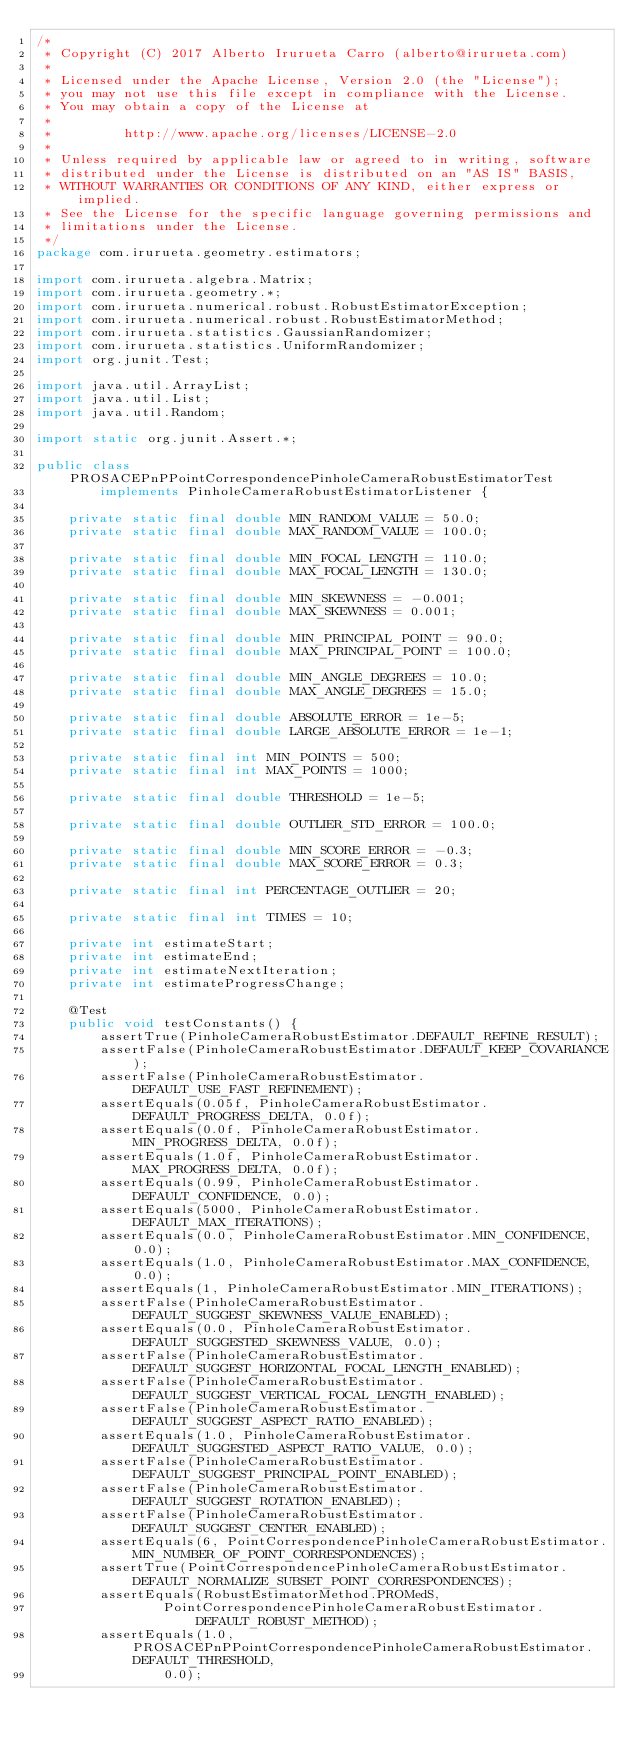Convert code to text. <code><loc_0><loc_0><loc_500><loc_500><_Java_>/*
 * Copyright (C) 2017 Alberto Irurueta Carro (alberto@irurueta.com)
 *
 * Licensed under the Apache License, Version 2.0 (the "License");
 * you may not use this file except in compliance with the License.
 * You may obtain a copy of the License at
 *
 *         http://www.apache.org/licenses/LICENSE-2.0
 *
 * Unless required by applicable law or agreed to in writing, software
 * distributed under the License is distributed on an "AS IS" BASIS,
 * WITHOUT WARRANTIES OR CONDITIONS OF ANY KIND, either express or implied.
 * See the License for the specific language governing permissions and
 * limitations under the License.
 */
package com.irurueta.geometry.estimators;

import com.irurueta.algebra.Matrix;
import com.irurueta.geometry.*;
import com.irurueta.numerical.robust.RobustEstimatorException;
import com.irurueta.numerical.robust.RobustEstimatorMethod;
import com.irurueta.statistics.GaussianRandomizer;
import com.irurueta.statistics.UniformRandomizer;
import org.junit.Test;

import java.util.ArrayList;
import java.util.List;
import java.util.Random;

import static org.junit.Assert.*;

public class PROSACEPnPPointCorrespondencePinholeCameraRobustEstimatorTest
        implements PinholeCameraRobustEstimatorListener {

    private static final double MIN_RANDOM_VALUE = 50.0;
    private static final double MAX_RANDOM_VALUE = 100.0;

    private static final double MIN_FOCAL_LENGTH = 110.0;
    private static final double MAX_FOCAL_LENGTH = 130.0;

    private static final double MIN_SKEWNESS = -0.001;
    private static final double MAX_SKEWNESS = 0.001;

    private static final double MIN_PRINCIPAL_POINT = 90.0;
    private static final double MAX_PRINCIPAL_POINT = 100.0;

    private static final double MIN_ANGLE_DEGREES = 10.0;
    private static final double MAX_ANGLE_DEGREES = 15.0;

    private static final double ABSOLUTE_ERROR = 1e-5;
    private static final double LARGE_ABSOLUTE_ERROR = 1e-1;

    private static final int MIN_POINTS = 500;
    private static final int MAX_POINTS = 1000;

    private static final double THRESHOLD = 1e-5;

    private static final double OUTLIER_STD_ERROR = 100.0;

    private static final double MIN_SCORE_ERROR = -0.3;
    private static final double MAX_SCORE_ERROR = 0.3;

    private static final int PERCENTAGE_OUTLIER = 20;

    private static final int TIMES = 10;

    private int estimateStart;
    private int estimateEnd;
    private int estimateNextIteration;
    private int estimateProgressChange;

    @Test
    public void testConstants() {
        assertTrue(PinholeCameraRobustEstimator.DEFAULT_REFINE_RESULT);
        assertFalse(PinholeCameraRobustEstimator.DEFAULT_KEEP_COVARIANCE);
        assertFalse(PinholeCameraRobustEstimator.DEFAULT_USE_FAST_REFINEMENT);
        assertEquals(0.05f, PinholeCameraRobustEstimator.DEFAULT_PROGRESS_DELTA, 0.0f);
        assertEquals(0.0f, PinholeCameraRobustEstimator.MIN_PROGRESS_DELTA, 0.0f);
        assertEquals(1.0f, PinholeCameraRobustEstimator.MAX_PROGRESS_DELTA, 0.0f);
        assertEquals(0.99, PinholeCameraRobustEstimator.DEFAULT_CONFIDENCE, 0.0);
        assertEquals(5000, PinholeCameraRobustEstimator.DEFAULT_MAX_ITERATIONS);
        assertEquals(0.0, PinholeCameraRobustEstimator.MIN_CONFIDENCE, 0.0);
        assertEquals(1.0, PinholeCameraRobustEstimator.MAX_CONFIDENCE, 0.0);
        assertEquals(1, PinholeCameraRobustEstimator.MIN_ITERATIONS);
        assertFalse(PinholeCameraRobustEstimator.DEFAULT_SUGGEST_SKEWNESS_VALUE_ENABLED);
        assertEquals(0.0, PinholeCameraRobustEstimator.DEFAULT_SUGGESTED_SKEWNESS_VALUE, 0.0);
        assertFalse(PinholeCameraRobustEstimator.DEFAULT_SUGGEST_HORIZONTAL_FOCAL_LENGTH_ENABLED);
        assertFalse(PinholeCameraRobustEstimator.DEFAULT_SUGGEST_VERTICAL_FOCAL_LENGTH_ENABLED);
        assertFalse(PinholeCameraRobustEstimator.DEFAULT_SUGGEST_ASPECT_RATIO_ENABLED);
        assertEquals(1.0, PinholeCameraRobustEstimator.DEFAULT_SUGGESTED_ASPECT_RATIO_VALUE, 0.0);
        assertFalse(PinholeCameraRobustEstimator.DEFAULT_SUGGEST_PRINCIPAL_POINT_ENABLED);
        assertFalse(PinholeCameraRobustEstimator.DEFAULT_SUGGEST_ROTATION_ENABLED);
        assertFalse(PinholeCameraRobustEstimator.DEFAULT_SUGGEST_CENTER_ENABLED);
        assertEquals(6, PointCorrespondencePinholeCameraRobustEstimator.MIN_NUMBER_OF_POINT_CORRESPONDENCES);
        assertTrue(PointCorrespondencePinholeCameraRobustEstimator.DEFAULT_NORMALIZE_SUBSET_POINT_CORRESPONDENCES);
        assertEquals(RobustEstimatorMethod.PROMedS,
                PointCorrespondencePinholeCameraRobustEstimator.DEFAULT_ROBUST_METHOD);
        assertEquals(1.0, PROSACEPnPPointCorrespondencePinholeCameraRobustEstimator.DEFAULT_THRESHOLD,
                0.0);</code> 